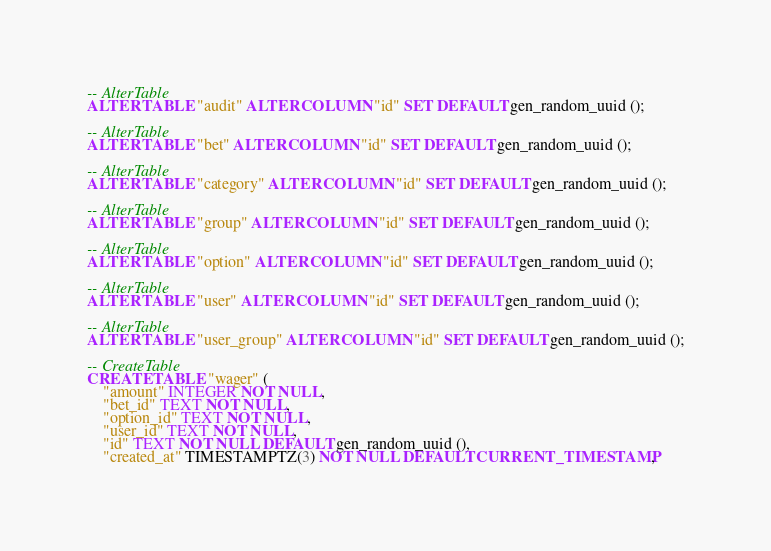Convert code to text. <code><loc_0><loc_0><loc_500><loc_500><_SQL_>-- AlterTable
ALTER TABLE "audit" ALTER COLUMN "id" SET DEFAULT gen_random_uuid ();

-- AlterTable
ALTER TABLE "bet" ALTER COLUMN "id" SET DEFAULT gen_random_uuid ();

-- AlterTable
ALTER TABLE "category" ALTER COLUMN "id" SET DEFAULT gen_random_uuid ();

-- AlterTable
ALTER TABLE "group" ALTER COLUMN "id" SET DEFAULT gen_random_uuid ();

-- AlterTable
ALTER TABLE "option" ALTER COLUMN "id" SET DEFAULT gen_random_uuid ();

-- AlterTable
ALTER TABLE "user" ALTER COLUMN "id" SET DEFAULT gen_random_uuid ();

-- AlterTable
ALTER TABLE "user_group" ALTER COLUMN "id" SET DEFAULT gen_random_uuid ();

-- CreateTable
CREATE TABLE "wager" (
    "amount" INTEGER NOT NULL,
    "bet_id" TEXT NOT NULL,
    "option_id" TEXT NOT NULL,
    "user_id" TEXT NOT NULL,
    "id" TEXT NOT NULL DEFAULT gen_random_uuid (),
    "created_at" TIMESTAMPTZ(3) NOT NULL DEFAULT CURRENT_TIMESTAMP,</code> 